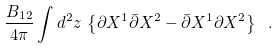Convert formula to latex. <formula><loc_0><loc_0><loc_500><loc_500>\frac { B _ { 1 2 } } { 4 \pi } \int d ^ { 2 } z \, \left \{ \partial X ^ { 1 } \bar { \partial } X ^ { 2 } - \bar { \partial } X ^ { 1 } \partial X ^ { 2 } \right \} \ .</formula> 